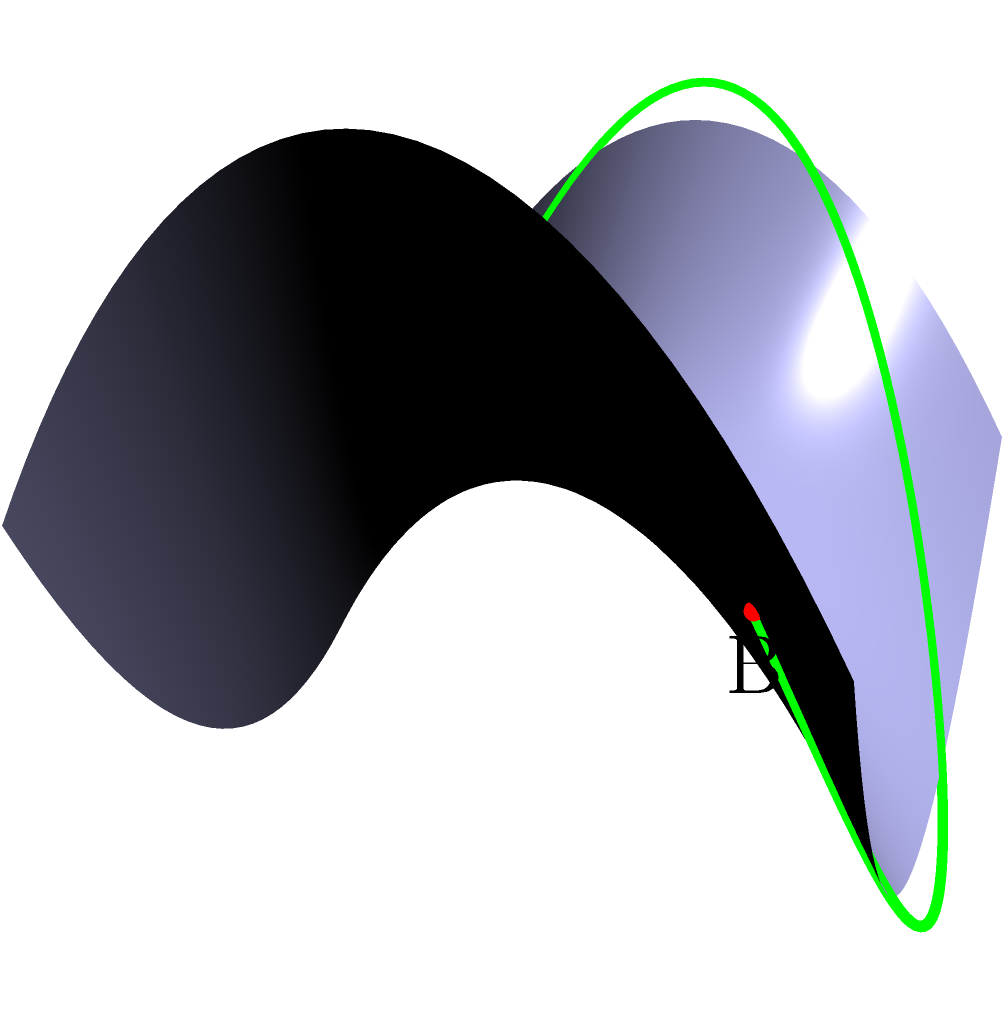You're looking at a map of Springfield's hilly terrain to plan the most efficient route for your wife's OBGYN visits. The map is represented by the surface $z = 0.5(x^2 - y^2)$. Points A and B represent your home and the OBGYN's office, respectively. What is the shape of the shortest path between these two points on this curved surface? To determine the shape of the shortest path between two points on a curved surface, we need to consider the principles of geodesics in non-Euclidean geometry. Let's break this down step-by-step:

1) In Euclidean geometry (flat surfaces), the shortest path between two points is a straight line. However, on curved surfaces, this is not always the case.

2) The surface given by the equation $z = 0.5(x^2 - y^2)$ is a hyperbolic paraboloid, often called a "saddle surface" due to its shape.

3) On a curved surface, the shortest path between two points is called a geodesic. Geodesics have the property that they locally minimize distance between points on the surface.

4) For a hyperbolic paraboloid, the geodesics are not straight lines when viewed from above. Instead, they form curves that may appear counterintuitive at first glance.

5) In this specific case, the geodesic between points A and B forms a curve that looks like an arc when projected onto the xy-plane.

6) This curved path allows the route to take advantage of the surface's geometry, minimizing the total distance traveled along the surface itself.

7) The green line in the diagram represents this geodesic path, which is indeed curved rather than straight.

Therefore, the shape of the shortest path between the two points on this curved surface is a curved arc, not a straight line.
Answer: Curved arc 